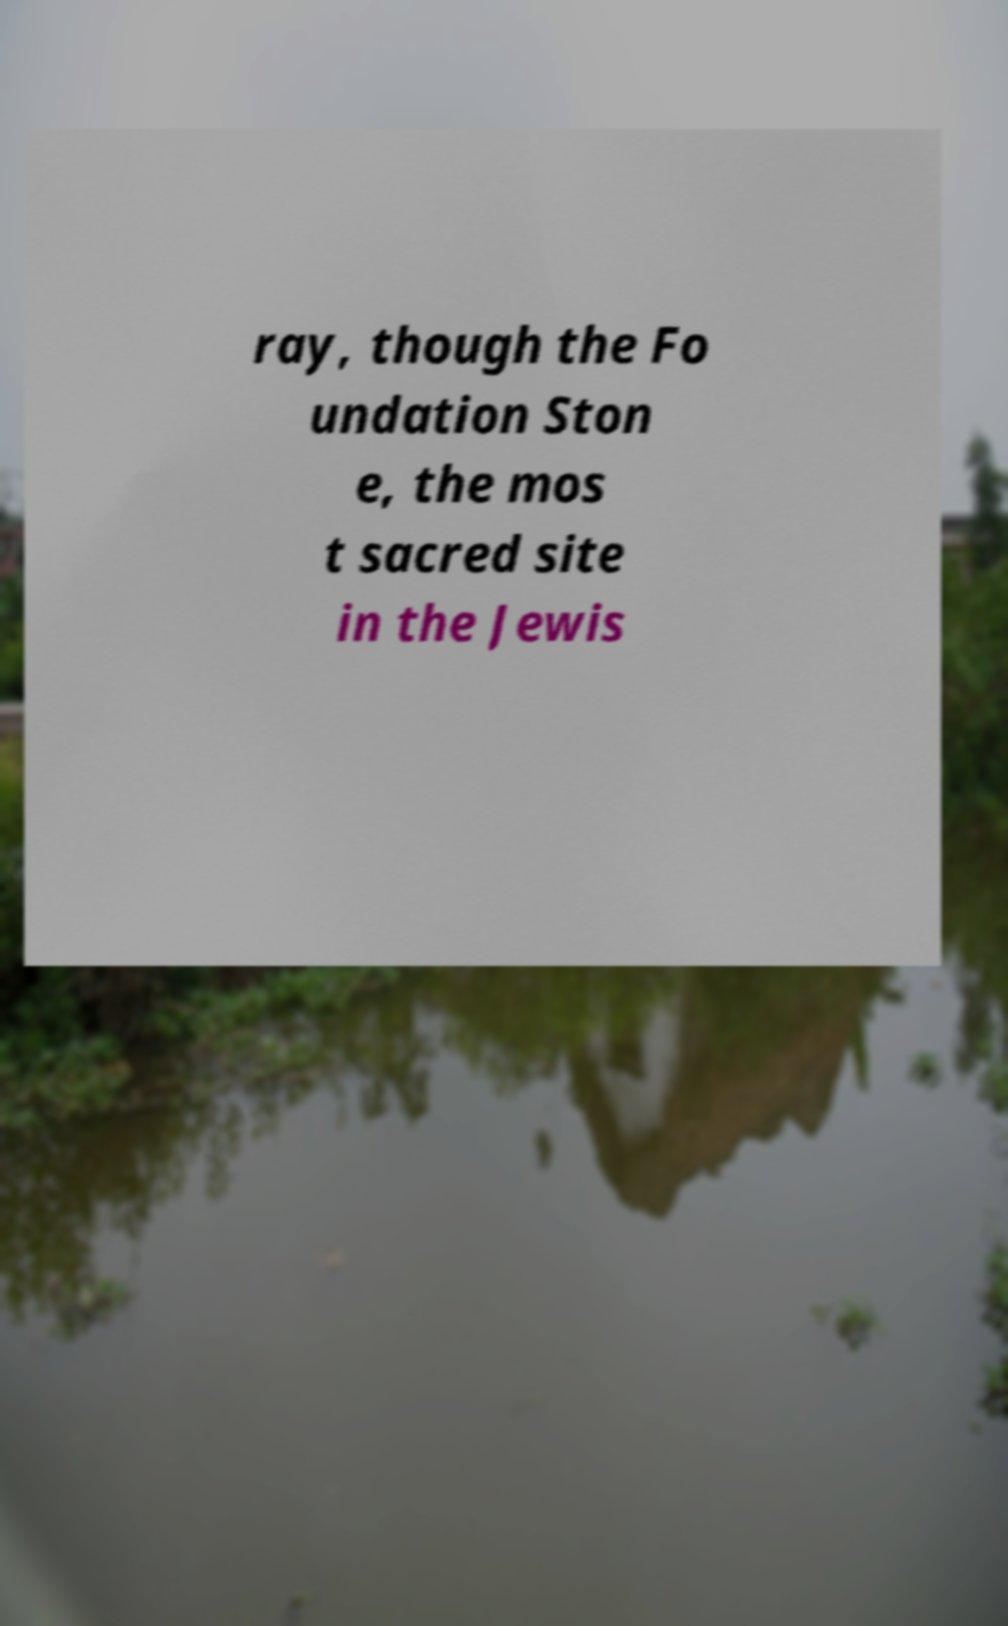Please identify and transcribe the text found in this image. ray, though the Fo undation Ston e, the mos t sacred site in the Jewis 